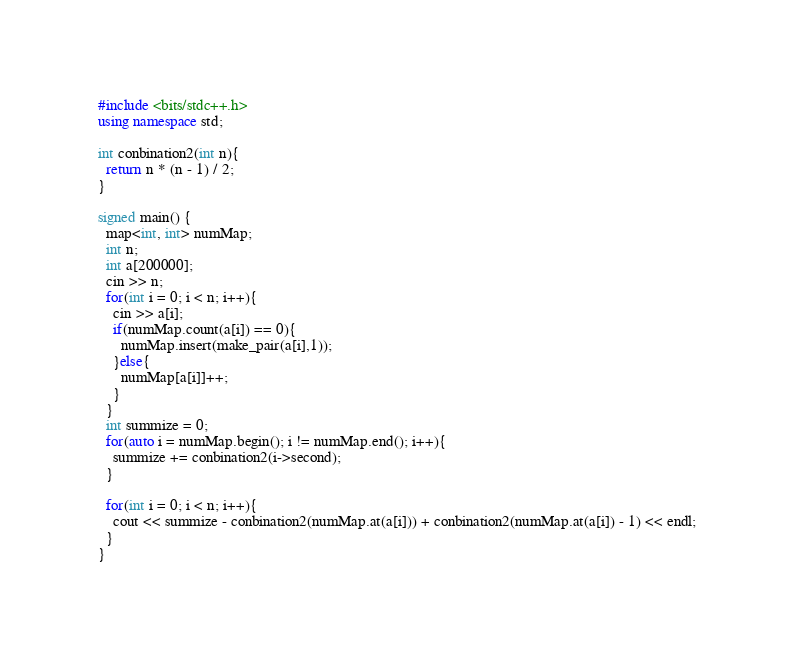<code> <loc_0><loc_0><loc_500><loc_500><_C++_>#include <bits/stdc++.h>
using namespace std;

int conbination2(int n){
  return n * (n - 1) / 2;
}

signed main() {
  map<int, int> numMap;
  int n;
  int a[200000];
  cin >> n;
  for(int i = 0; i < n; i++){
    cin >> a[i];
    if(numMap.count(a[i]) == 0){
      numMap.insert(make_pair(a[i],1));
    }else{
      numMap[a[i]]++;
    }
  }
  int summize = 0;
  for(auto i = numMap.begin(); i != numMap.end(); i++){
    summize += conbination2(i->second);
  }

  for(int i = 0; i < n; i++){
    cout << summize - conbination2(numMap.at(a[i])) + conbination2(numMap.at(a[i]) - 1) << endl;
  }
}</code> 